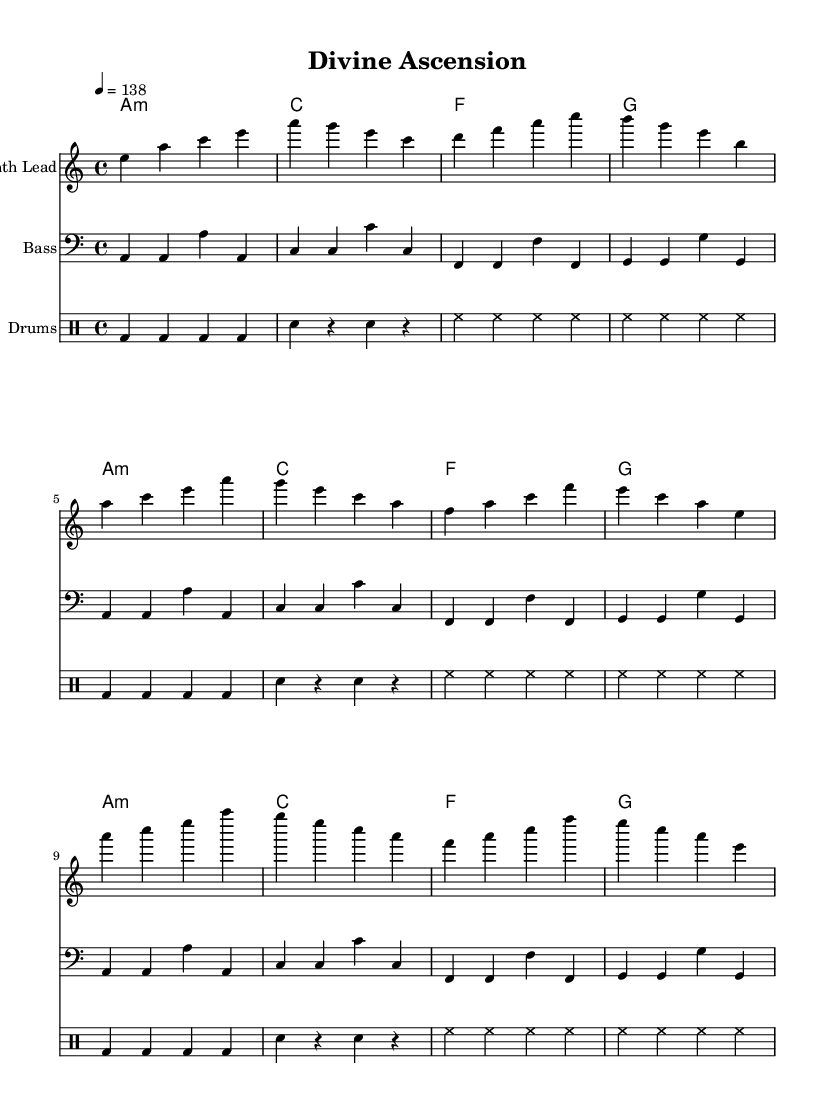What is the key signature of this music? The key signature is A minor, which has no sharps or flats.
Answer: A minor What is the time signature? The time signature is 4/4, indicating there are four beats per measure.
Answer: 4/4 What is the tempo marking in beats per minute? The tempo marking is given as a quarter note equals 138 beats per minute.
Answer: 138 How many measures are in the melody section? By counting the measures in the melody part, there are a total of 12 measures presented.
Answer: 12 What is the primary instrument for the melody? The melody is specified to be played on a "Synth Lead," indicating an electronic synthesizer instrument.
Answer: Synth Lead In which section does the melody first begin? The melody first begins in the "Intro" section, as indicated in the provided excerpt.
Answer: Intro How many different chords are represented in the chord progression? The chord progression lists four distinct chords that repeat: A minor, C, F, and G.
Answer: 4 